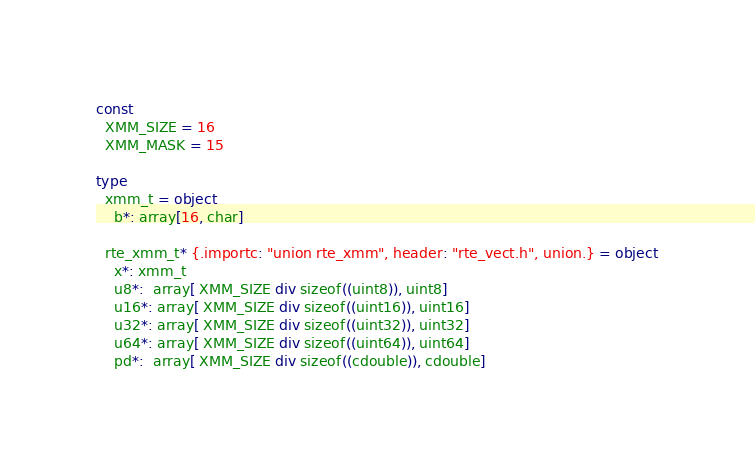Convert code to text. <code><loc_0><loc_0><loc_500><loc_500><_Nim_>const
  XMM_SIZE = 16
  XMM_MASK = 15

type
  xmm_t = object
    b*: array[16, char]

  rte_xmm_t* {.importc: "union rte_xmm", header: "rte_vect.h", union.} = object
    x*: xmm_t
    u8*:  array[ XMM_SIZE div sizeof((uint8)), uint8]
    u16*: array[ XMM_SIZE div sizeof((uint16)), uint16]
    u32*: array[ XMM_SIZE div sizeof((uint32)), uint32]
    u64*: array[ XMM_SIZE div sizeof((uint64)), uint64]
    pd*:  array[ XMM_SIZE div sizeof((cdouble)), cdouble]

</code> 